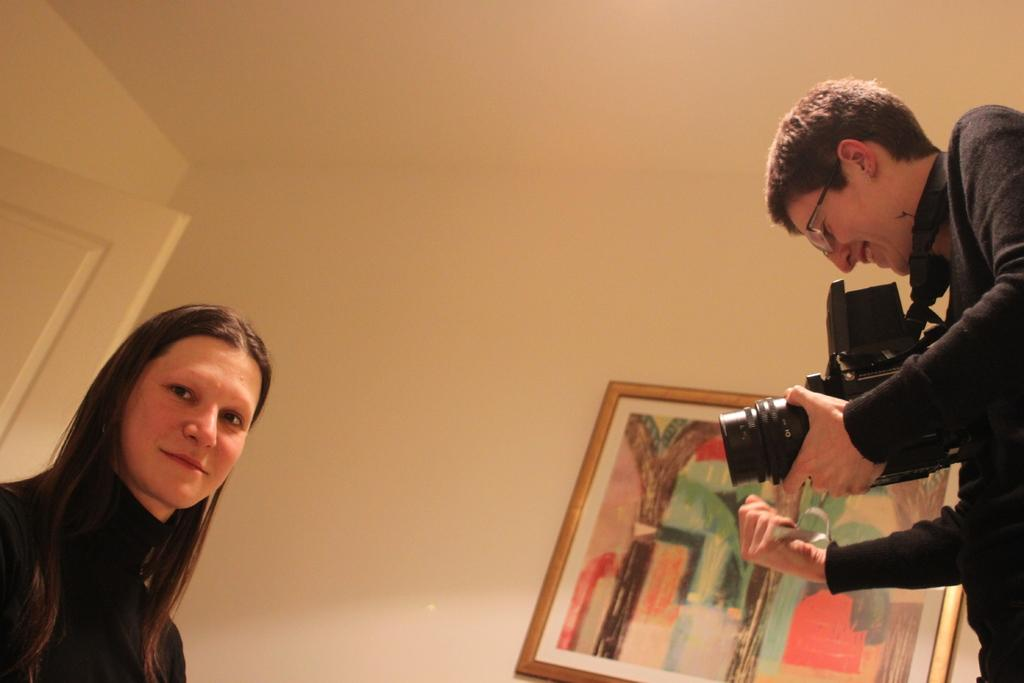How many people are in the image wearing black color dresses? There are two people with black color dresses in the image. What is one person doing in the image? One person is holding a camera in the image. What can be seen on the wall in the background of the image? There is a frame on the wall in the background of the image. What type of mask is the person wearing in the image? There is no mask present in the image. 